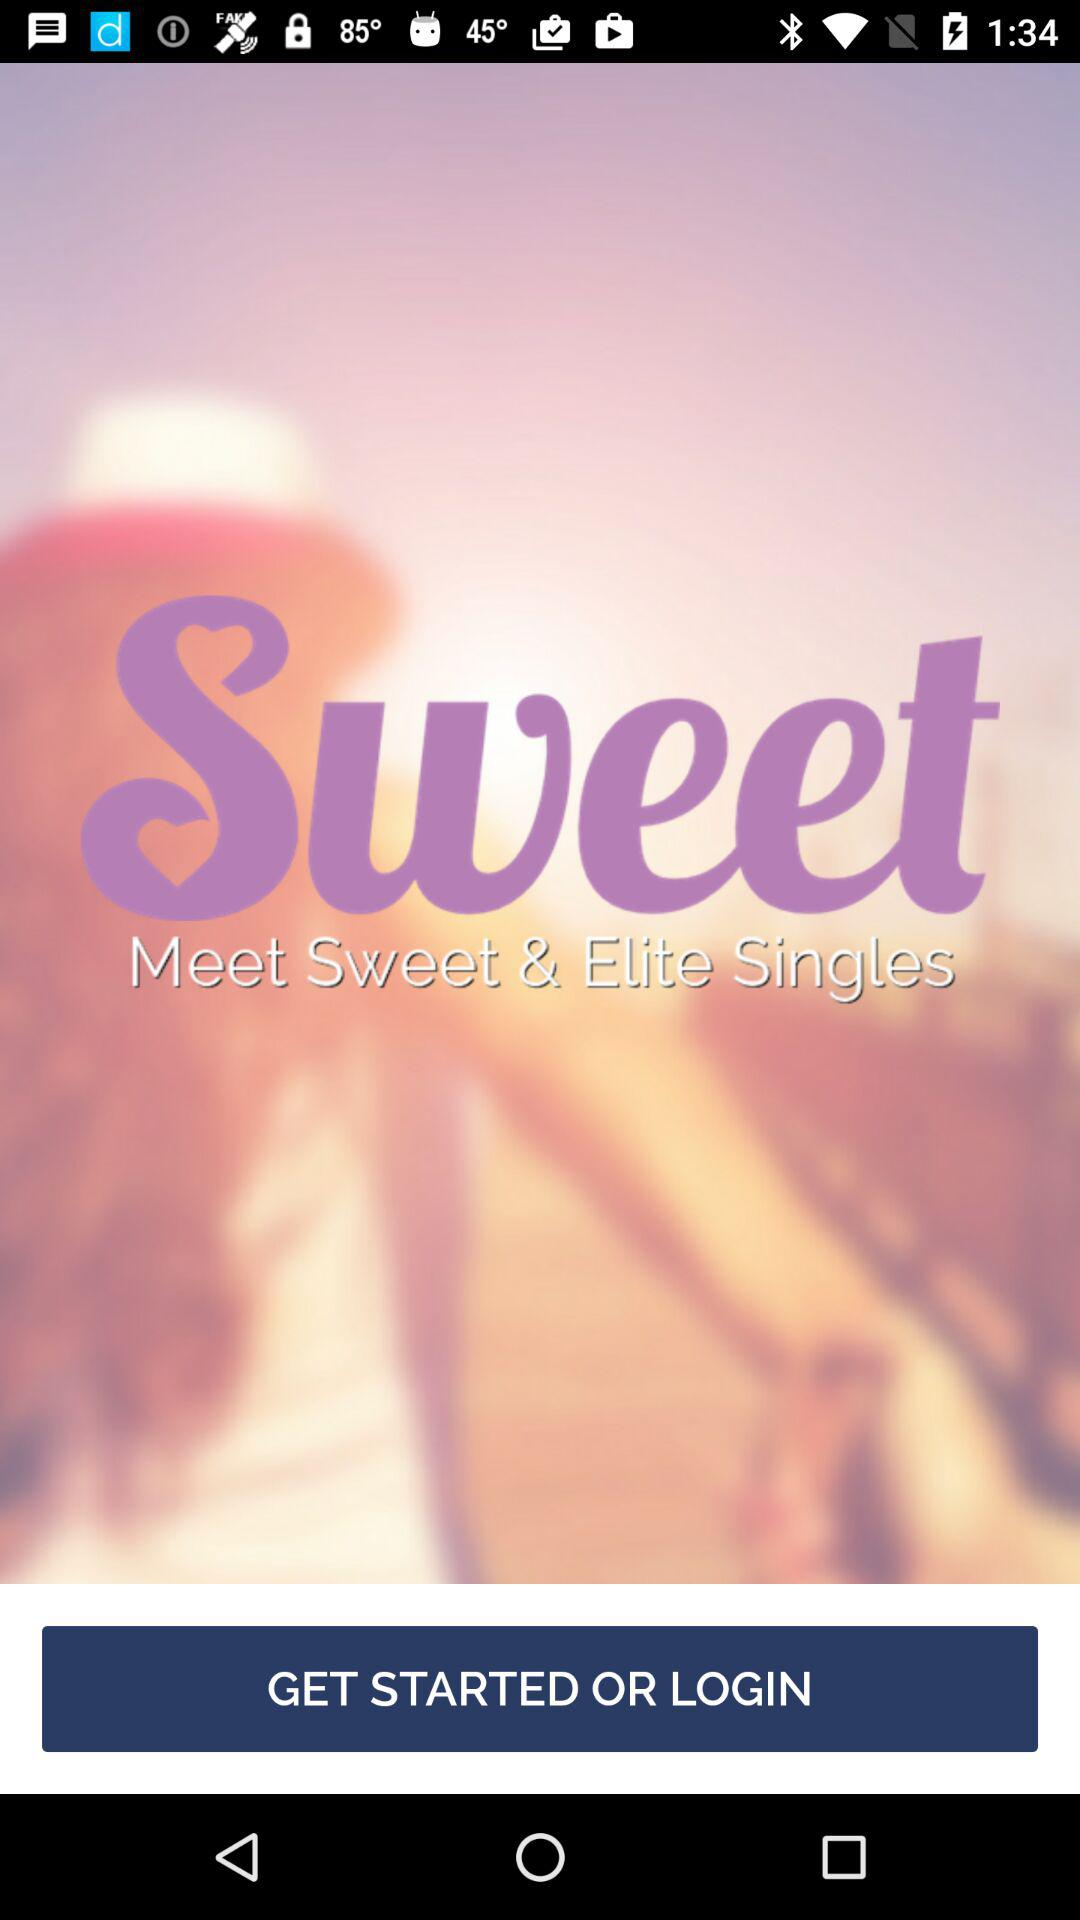What is the name of the application? The name of the application is "Sweet". 